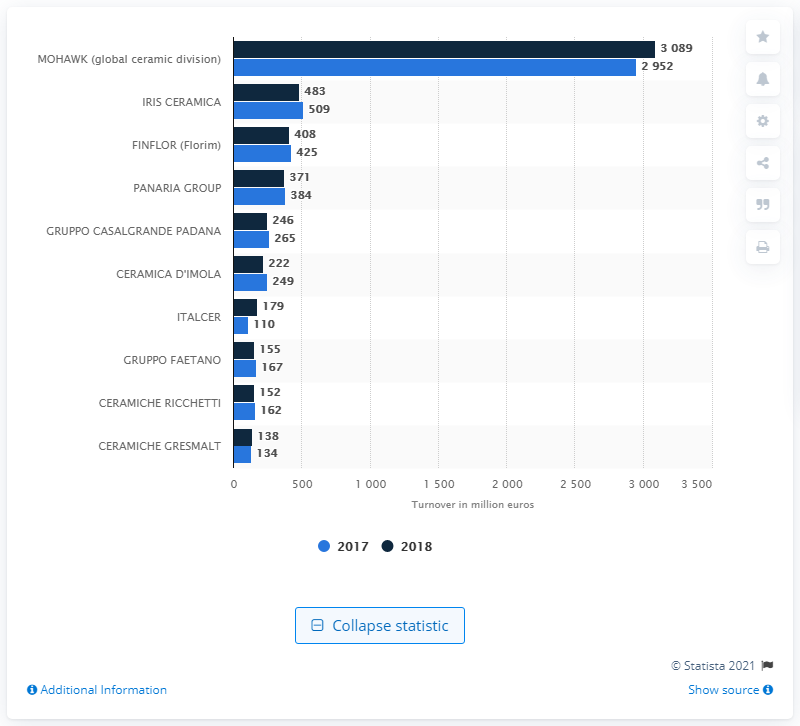List a handful of essential elements in this visual. Iris Ceramica's turnover in 2018 was 483. 